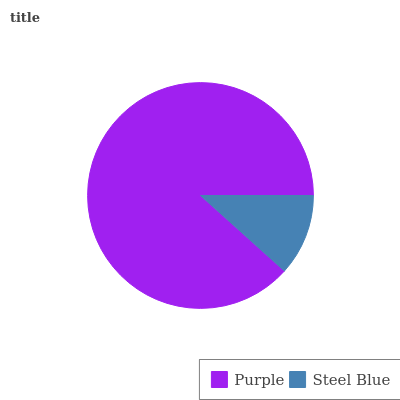Is Steel Blue the minimum?
Answer yes or no. Yes. Is Purple the maximum?
Answer yes or no. Yes. Is Steel Blue the maximum?
Answer yes or no. No. Is Purple greater than Steel Blue?
Answer yes or no. Yes. Is Steel Blue less than Purple?
Answer yes or no. Yes. Is Steel Blue greater than Purple?
Answer yes or no. No. Is Purple less than Steel Blue?
Answer yes or no. No. Is Purple the high median?
Answer yes or no. Yes. Is Steel Blue the low median?
Answer yes or no. Yes. Is Steel Blue the high median?
Answer yes or no. No. Is Purple the low median?
Answer yes or no. No. 